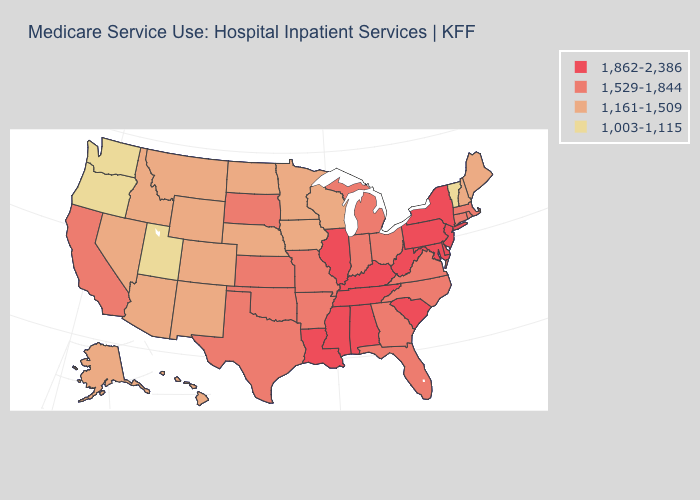Does Arizona have a higher value than Utah?
Concise answer only. Yes. What is the value of New Hampshire?
Short answer required. 1,161-1,509. Name the states that have a value in the range 1,529-1,844?
Quick response, please. Arkansas, California, Connecticut, Florida, Georgia, Indiana, Kansas, Massachusetts, Michigan, Missouri, North Carolina, Ohio, Oklahoma, Rhode Island, South Dakota, Texas, Virginia. Does Rhode Island have a higher value than Wisconsin?
Quick response, please. Yes. What is the highest value in the USA?
Quick response, please. 1,862-2,386. Name the states that have a value in the range 1,862-2,386?
Write a very short answer. Alabama, Delaware, Illinois, Kentucky, Louisiana, Maryland, Mississippi, New Jersey, New York, Pennsylvania, South Carolina, Tennessee, West Virginia. Among the states that border Pennsylvania , which have the lowest value?
Write a very short answer. Ohio. Among the states that border Georgia , which have the lowest value?
Answer briefly. Florida, North Carolina. How many symbols are there in the legend?
Keep it brief. 4. Does Oregon have the lowest value in the USA?
Concise answer only. Yes. What is the value of Connecticut?
Answer briefly. 1,529-1,844. Does the map have missing data?
Give a very brief answer. No. Which states have the lowest value in the USA?
Keep it brief. Oregon, Utah, Vermont, Washington. Does South Carolina have a lower value than New Mexico?
Write a very short answer. No. Does Montana have the highest value in the West?
Give a very brief answer. No. 